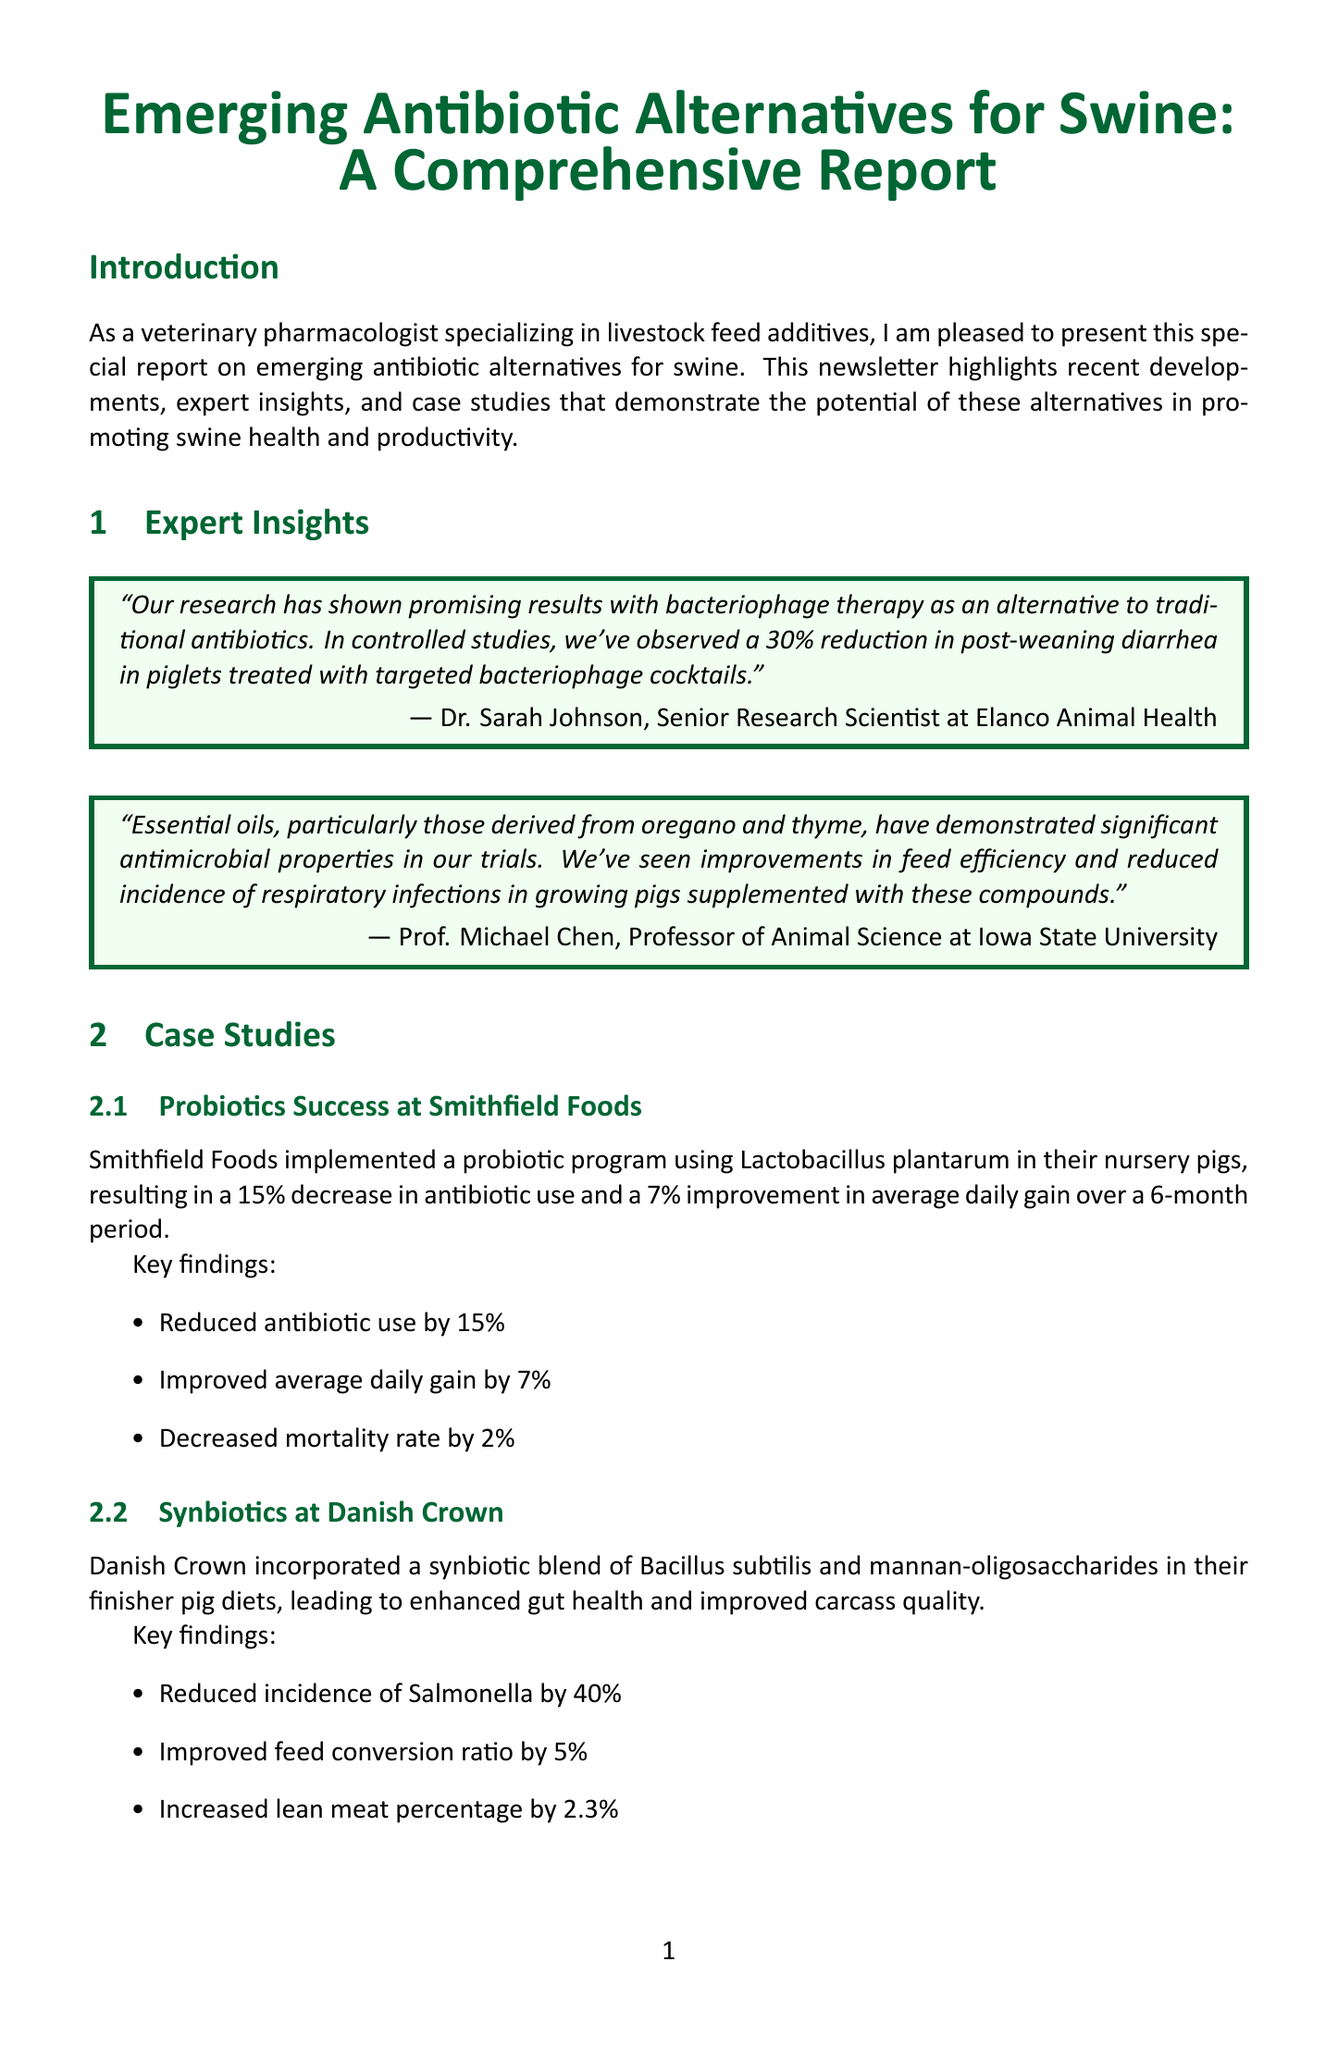What is the title of the newsletter? The title of the newsletter is presented in the document as the header, which is "Emerging Antibiotic Alternatives for Swine: A Comprehensive Report."
Answer: Emerging Antibiotic Alternatives for Swine: A Comprehensive Report Who is the Senior Research Scientist interviewed in the newsletter? The newsletter includes an interview section where the Senior Research Scientist at Elanco Animal Health is mentioned as Dr. Sarah Johnson.
Answer: Dr. Sarah Johnson What percentage reduction in post-weaning diarrhea was observed with bacteriophage therapy? The document states the results of bacteriophage therapy, noting a specific percentage reduction in post-weaning diarrhea observed in controlled studies.
Answer: 30% Which essential oils were mentioned for antimicrobial properties? The expert interview highlights particular essential oils that demonstrated significant antimicrobial properties in trials, specifically oregano and thyme.
Answer: Oregano and thyme What was the mortality rate decrease achieved in the probiotics case study at Smithfield Foods? The case study regarding probiotics at Smithfield Foods lists the results, including a specific figure for decreased mortality rate over the program period.
Answer: 2% What is the potential impact of CRISPR-Cas based antimicrobials? The document discusses emerging technologies, stating that the potential impact of CRISPR-Cas based antimicrobials could revolutionize pathogen control in swine production.
Answer: Minimize the risk of antimicrobial resistance How much funding has been increased for research on antibiotic alternatives according to regulatory updates? The regulatory updates mention that there is increased funding for research on antibiotic alternatives as part of the new FDA guidelines.
Answer: Increased funding What is the focus of the conclusion in the newsletter? The conclusion summarizes the overall theme discussed throughout the newsletter and indicates the importance of a multifaceted approach in exploring alternatives.
Answer: Multifaceted approach combining probiotics, essential oils, bacteriophages, and emerging technologies 